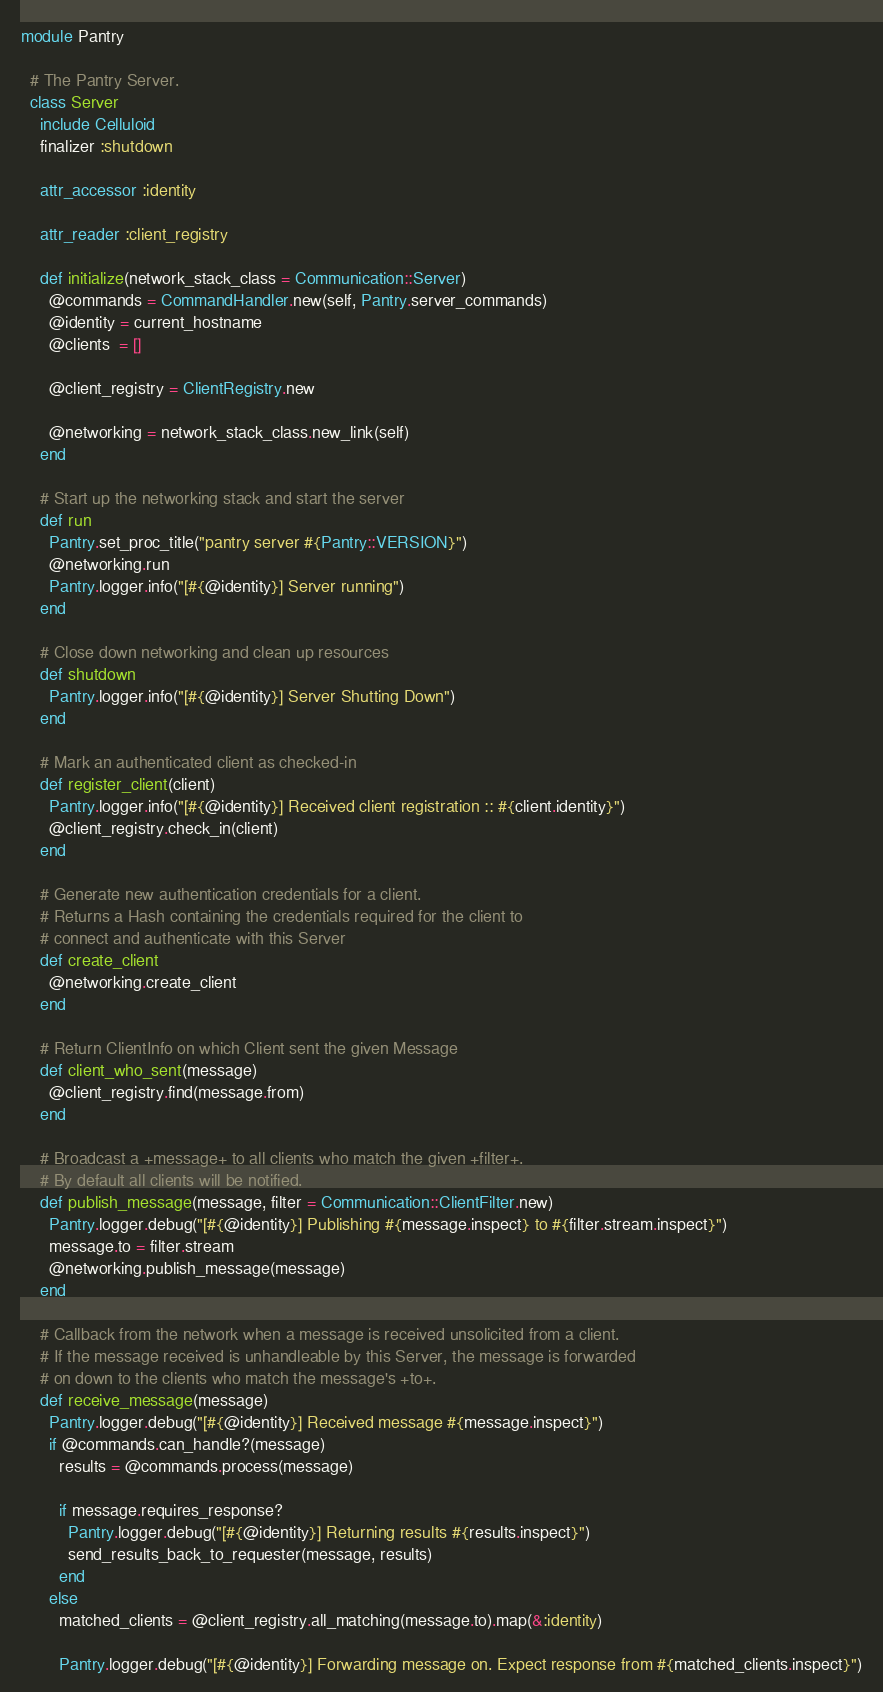Convert code to text. <code><loc_0><loc_0><loc_500><loc_500><_Ruby_>module Pantry

  # The Pantry Server.
  class Server
    include Celluloid
    finalizer :shutdown

    attr_accessor :identity

    attr_reader :client_registry

    def initialize(network_stack_class = Communication::Server)
      @commands = CommandHandler.new(self, Pantry.server_commands)
      @identity = current_hostname
      @clients  = []

      @client_registry = ClientRegistry.new

      @networking = network_stack_class.new_link(self)
    end

    # Start up the networking stack and start the server
    def run
      Pantry.set_proc_title("pantry server #{Pantry::VERSION}")
      @networking.run
      Pantry.logger.info("[#{@identity}] Server running")
    end

    # Close down networking and clean up resources
    def shutdown
      Pantry.logger.info("[#{@identity}] Server Shutting Down")
    end

    # Mark an authenticated client as checked-in
    def register_client(client)
      Pantry.logger.info("[#{@identity}] Received client registration :: #{client.identity}")
      @client_registry.check_in(client)
    end

    # Generate new authentication credentials for a client.
    # Returns a Hash containing the credentials required for the client to
    # connect and authenticate with this Server
    def create_client
      @networking.create_client
    end

    # Return ClientInfo on which Client sent the given Message
    def client_who_sent(message)
      @client_registry.find(message.from)
    end

    # Broadcast a +message+ to all clients who match the given +filter+.
    # By default all clients will be notified.
    def publish_message(message, filter = Communication::ClientFilter.new)
      Pantry.logger.debug("[#{@identity}] Publishing #{message.inspect} to #{filter.stream.inspect}")
      message.to = filter.stream
      @networking.publish_message(message)
    end

    # Callback from the network when a message is received unsolicited from a client.
    # If the message received is unhandleable by this Server, the message is forwarded
    # on down to the clients who match the message's +to+.
    def receive_message(message)
      Pantry.logger.debug("[#{@identity}] Received message #{message.inspect}")
      if @commands.can_handle?(message)
        results = @commands.process(message)

        if message.requires_response?
          Pantry.logger.debug("[#{@identity}] Returning results #{results.inspect}")
          send_results_back_to_requester(message, results)
        end
      else
        matched_clients = @client_registry.all_matching(message.to).map(&:identity)

        Pantry.logger.debug("[#{@identity}] Forwarding message on. Expect response from #{matched_clients.inspect}")</code> 